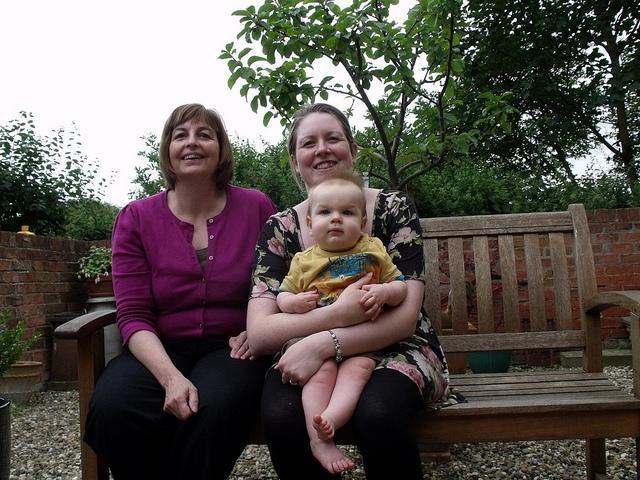How many people are on this bench?
Give a very brief answer. 3. How many people can be seen?
Give a very brief answer. 2. How many sheep are in the photo?
Give a very brief answer. 0. 